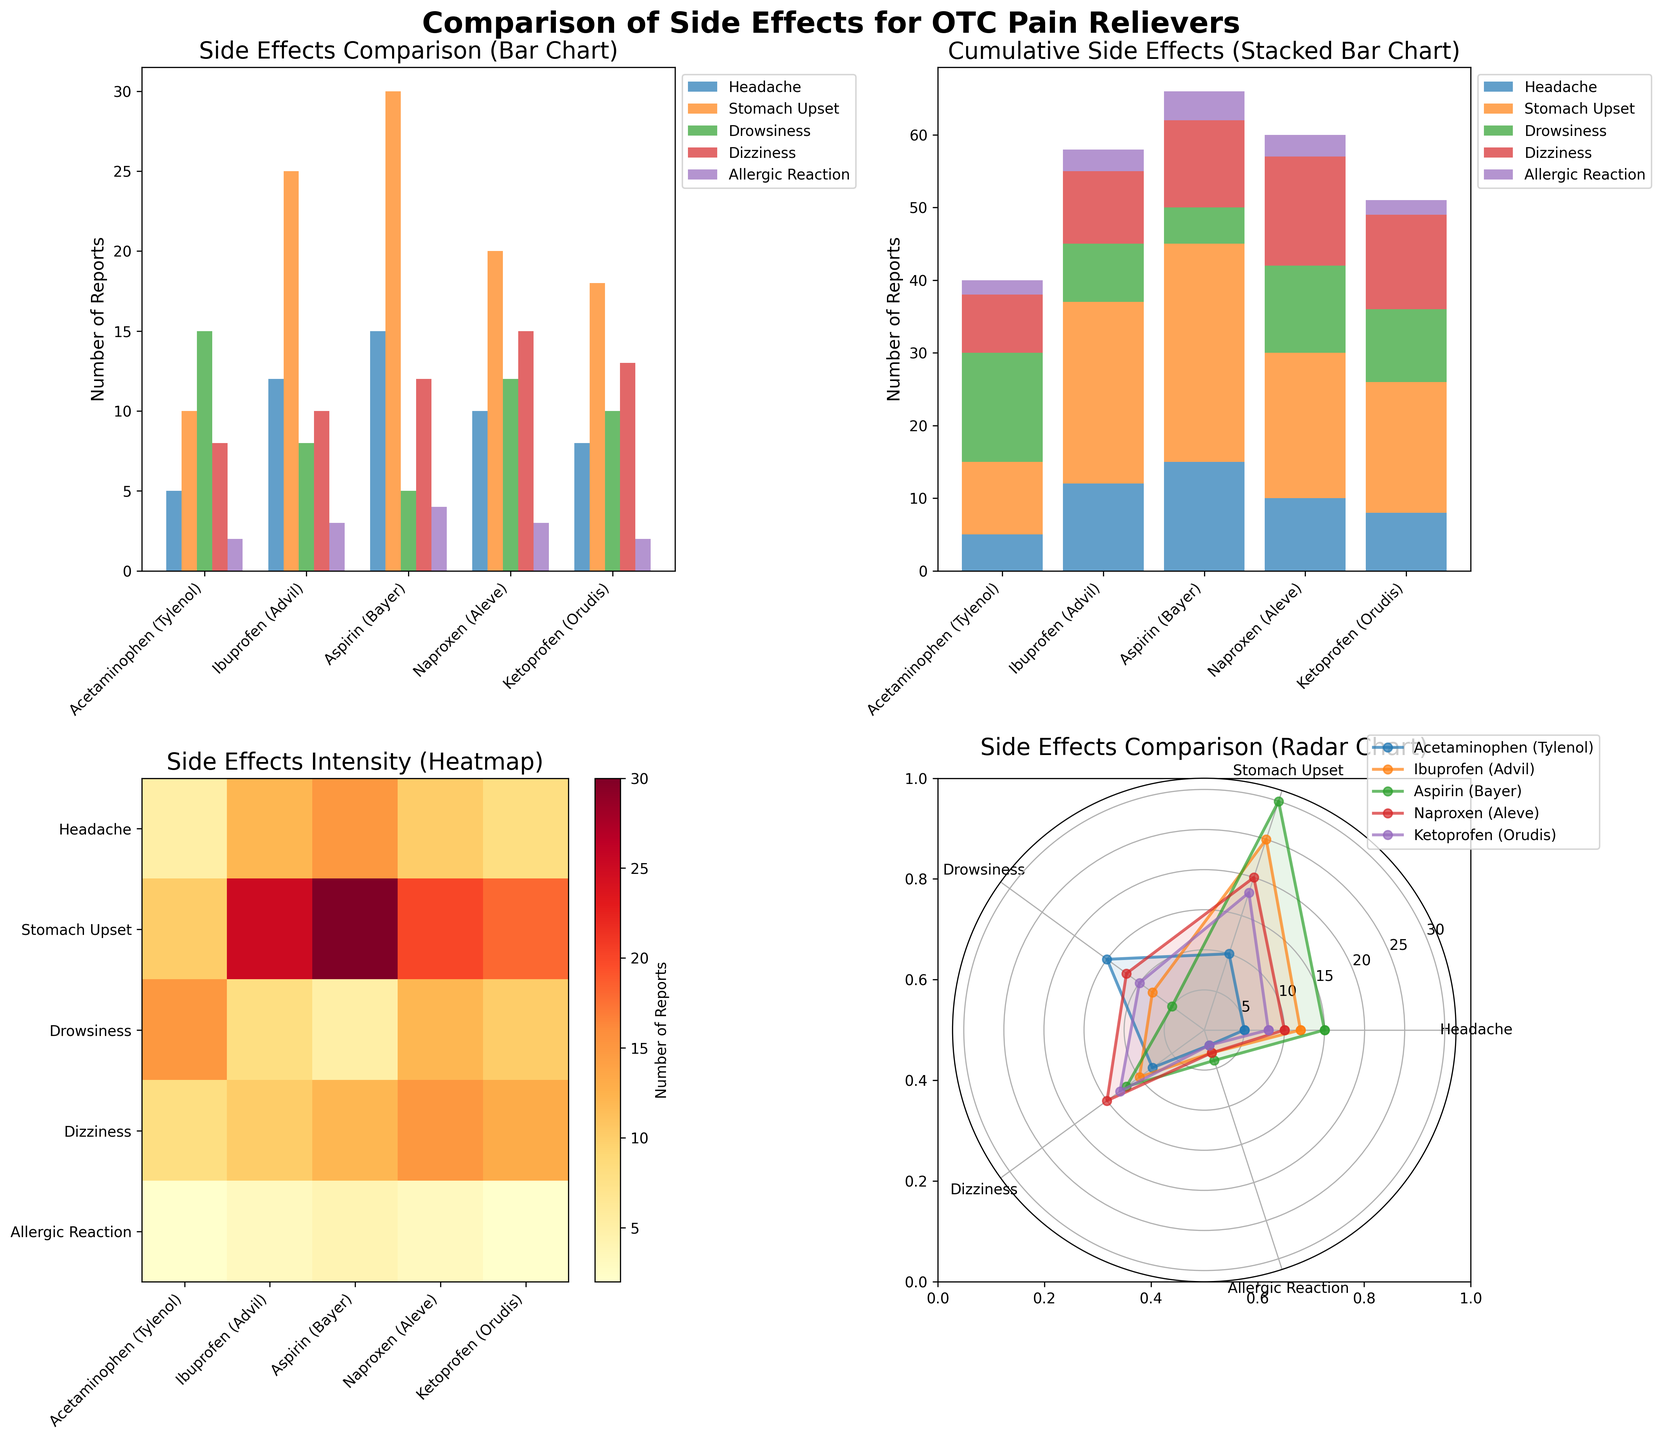What is the title of the entire figure? The title is placed at the very top of the figure and it's set to be bold and large for clear visibility.
Answer: Comparison of Side Effects for OTC Pain Relievers Which drug has the highest number of reports for stomach upset in the bar chart? Observing the bar chart, focus on the bars representing "Stomach Upset" and identify the tallest one.
Answer: Aspirin (Bayer) How many side effects are reported for Ketoprofen (Orudis) in total according to the stacked bar chart? Sum the values from each section of the stacked bar corresponding to "Ketoprofen (Orudis)": 8 (Headache) + 18 (Stomach Upset) + 10 (Drowsiness) + 13 (Dizziness) + 2 (Allergic Reaction) = 51 reports.
Answer: 51 Which two drugs have equal reports of allergic reactions, and how many for each, according to the heatmap? Check the intensity and labels for "Allergic Reaction" row to spot identical colors and values, indicating equal numbers. The value for both should be 2.
Answer: Acetaminophen (Tylenol) and Ketoprofen (Orudis), with 2 reports each Among the side effects reported for Ibuprofen (Advil), what is the difference between the number of reports for dizziness and drowsiness in the radar chart? Locate the points representing "Dizziness" and "Drowsiness" for Ibuprofen (Advil) in the radar chart. Then, subtract the smaller value (8 for Drowsiness) from the larger value (10 for Dizziness).
Answer: 2 Which drug has the second highest number of headache reports according to any variant of the charts? Locate the values or bar heights representing headache reports across all charts. The highest is for Aspirin (15), and the second highest value is for Ibuprofen (12).
Answer: Ibuprofen (Advil) How many more stomach upset reports does Naproxen (Aleve) have compared to Acetaminophen (Tylenol), based on the bar chart? Identify the values labeled "Stomach Upset" for both drugs and subtract the smaller value (10 for Acetaminophen) from the larger one (20 for Naproxen).
Answer: 10 In the heatmap, which side effect has the lightest color, indicating the least number of reports overall? In the heatmap, locate the row that is consistently the lightest in shade, which represents the fewest number of overall reports.
Answer: Allergic Reaction How many unique drugs are compared in the entire figure? Count the number of unique drug names listed along the x-axis or within the legend across any of the charts.
Answer: 5 Is the distribution of side effects more balanced across drugs in the heatmap or the radar chart? Assess both charts: the heatmap visually shows distribution intensity by color, while the radar chart shows side-effects spread radially. The stacked amounts in the heatmap typically illustrate a more balanced distribution.
Answer: Heatmap 